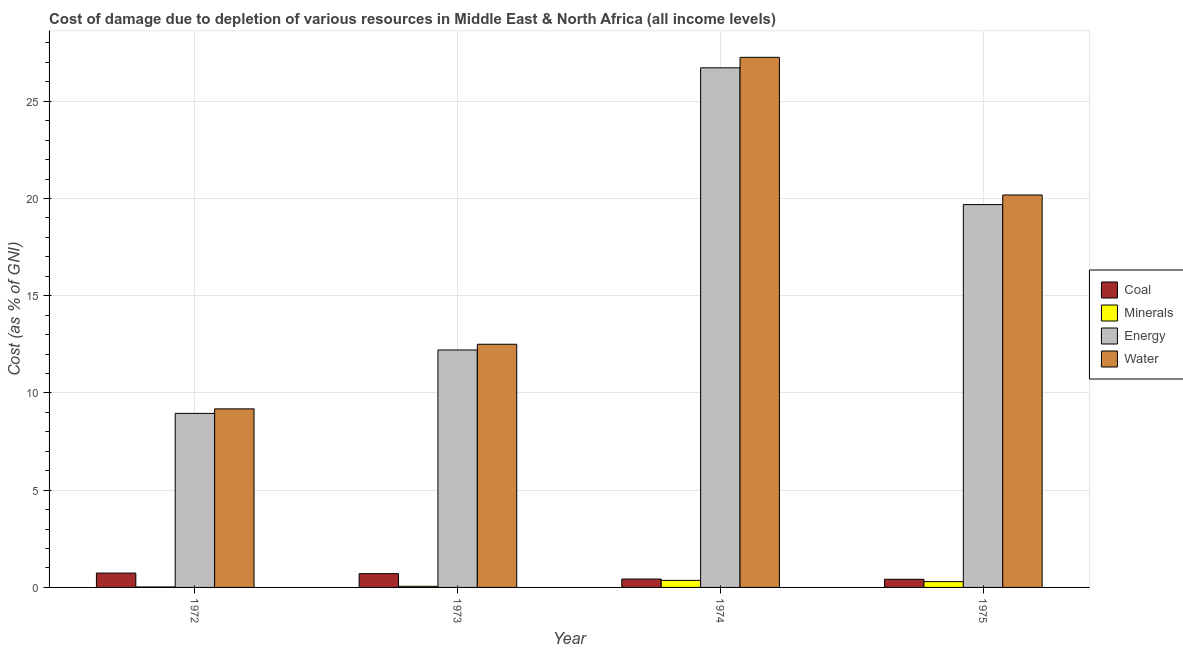How many different coloured bars are there?
Your response must be concise. 4. Are the number of bars on each tick of the X-axis equal?
Offer a very short reply. Yes. How many bars are there on the 3rd tick from the left?
Ensure brevity in your answer.  4. What is the label of the 1st group of bars from the left?
Ensure brevity in your answer.  1972. What is the cost of damage due to depletion of water in 1974?
Offer a terse response. 27.26. Across all years, what is the maximum cost of damage due to depletion of minerals?
Your response must be concise. 0.36. Across all years, what is the minimum cost of damage due to depletion of water?
Your answer should be very brief. 9.18. In which year was the cost of damage due to depletion of energy maximum?
Your answer should be compact. 1974. In which year was the cost of damage due to depletion of coal minimum?
Offer a terse response. 1975. What is the total cost of damage due to depletion of coal in the graph?
Provide a succinct answer. 2.3. What is the difference between the cost of damage due to depletion of water in 1972 and that in 1973?
Keep it short and to the point. -3.32. What is the difference between the cost of damage due to depletion of water in 1974 and the cost of damage due to depletion of minerals in 1972?
Offer a terse response. 18.08. What is the average cost of damage due to depletion of water per year?
Provide a short and direct response. 17.28. In how many years, is the cost of damage due to depletion of coal greater than 11 %?
Provide a succinct answer. 0. What is the ratio of the cost of damage due to depletion of coal in 1973 to that in 1975?
Provide a succinct answer. 1.69. Is the cost of damage due to depletion of coal in 1972 less than that in 1973?
Provide a succinct answer. No. What is the difference between the highest and the second highest cost of damage due to depletion of minerals?
Your answer should be very brief. 0.06. What is the difference between the highest and the lowest cost of damage due to depletion of coal?
Your answer should be compact. 0.32. Is the sum of the cost of damage due to depletion of water in 1972 and 1974 greater than the maximum cost of damage due to depletion of energy across all years?
Give a very brief answer. Yes. What does the 3rd bar from the left in 1975 represents?
Your response must be concise. Energy. What does the 1st bar from the right in 1975 represents?
Provide a short and direct response. Water. Is it the case that in every year, the sum of the cost of damage due to depletion of coal and cost of damage due to depletion of minerals is greater than the cost of damage due to depletion of energy?
Keep it short and to the point. No. How many years are there in the graph?
Give a very brief answer. 4. What is the difference between two consecutive major ticks on the Y-axis?
Provide a short and direct response. 5. Are the values on the major ticks of Y-axis written in scientific E-notation?
Provide a succinct answer. No. Does the graph contain grids?
Give a very brief answer. Yes. How many legend labels are there?
Provide a short and direct response. 4. How are the legend labels stacked?
Ensure brevity in your answer.  Vertical. What is the title of the graph?
Ensure brevity in your answer.  Cost of damage due to depletion of various resources in Middle East & North Africa (all income levels) . Does "Industry" appear as one of the legend labels in the graph?
Keep it short and to the point. No. What is the label or title of the Y-axis?
Offer a terse response. Cost (as % of GNI). What is the Cost (as % of GNI) in Coal in 1972?
Offer a terse response. 0.74. What is the Cost (as % of GNI) in Minerals in 1972?
Make the answer very short. 0.02. What is the Cost (as % of GNI) in Energy in 1972?
Offer a very short reply. 8.95. What is the Cost (as % of GNI) in Water in 1972?
Your answer should be very brief. 9.18. What is the Cost (as % of GNI) of Coal in 1973?
Offer a very short reply. 0.71. What is the Cost (as % of GNI) of Minerals in 1973?
Ensure brevity in your answer.  0.06. What is the Cost (as % of GNI) in Energy in 1973?
Offer a terse response. 12.21. What is the Cost (as % of GNI) of Water in 1973?
Offer a terse response. 12.5. What is the Cost (as % of GNI) in Coal in 1974?
Your answer should be compact. 0.43. What is the Cost (as % of GNI) in Minerals in 1974?
Your response must be concise. 0.36. What is the Cost (as % of GNI) of Energy in 1974?
Provide a succinct answer. 26.72. What is the Cost (as % of GNI) in Water in 1974?
Your answer should be compact. 27.26. What is the Cost (as % of GNI) in Coal in 1975?
Your answer should be very brief. 0.42. What is the Cost (as % of GNI) in Minerals in 1975?
Offer a terse response. 0.3. What is the Cost (as % of GNI) in Energy in 1975?
Your response must be concise. 19.69. What is the Cost (as % of GNI) of Water in 1975?
Make the answer very short. 20.18. Across all years, what is the maximum Cost (as % of GNI) of Coal?
Provide a short and direct response. 0.74. Across all years, what is the maximum Cost (as % of GNI) of Minerals?
Your response must be concise. 0.36. Across all years, what is the maximum Cost (as % of GNI) in Energy?
Provide a short and direct response. 26.72. Across all years, what is the maximum Cost (as % of GNI) of Water?
Provide a succinct answer. 27.26. Across all years, what is the minimum Cost (as % of GNI) of Coal?
Provide a short and direct response. 0.42. Across all years, what is the minimum Cost (as % of GNI) in Minerals?
Provide a succinct answer. 0.02. Across all years, what is the minimum Cost (as % of GNI) in Energy?
Offer a terse response. 8.95. Across all years, what is the minimum Cost (as % of GNI) in Water?
Offer a very short reply. 9.18. What is the total Cost (as % of GNI) in Coal in the graph?
Your answer should be very brief. 2.3. What is the total Cost (as % of GNI) of Minerals in the graph?
Provide a short and direct response. 0.74. What is the total Cost (as % of GNI) in Energy in the graph?
Provide a succinct answer. 67.57. What is the total Cost (as % of GNI) in Water in the graph?
Your response must be concise. 69.13. What is the difference between the Cost (as % of GNI) of Coal in 1972 and that in 1973?
Offer a terse response. 0.03. What is the difference between the Cost (as % of GNI) of Minerals in 1972 and that in 1973?
Ensure brevity in your answer.  -0.03. What is the difference between the Cost (as % of GNI) of Energy in 1972 and that in 1973?
Your answer should be compact. -3.26. What is the difference between the Cost (as % of GNI) in Water in 1972 and that in 1973?
Give a very brief answer. -3.32. What is the difference between the Cost (as % of GNI) of Coal in 1972 and that in 1974?
Provide a short and direct response. 0.31. What is the difference between the Cost (as % of GNI) of Minerals in 1972 and that in 1974?
Make the answer very short. -0.34. What is the difference between the Cost (as % of GNI) in Energy in 1972 and that in 1974?
Keep it short and to the point. -17.77. What is the difference between the Cost (as % of GNI) in Water in 1972 and that in 1974?
Provide a succinct answer. -18.08. What is the difference between the Cost (as % of GNI) of Coal in 1972 and that in 1975?
Ensure brevity in your answer.  0.32. What is the difference between the Cost (as % of GNI) of Minerals in 1972 and that in 1975?
Make the answer very short. -0.27. What is the difference between the Cost (as % of GNI) in Energy in 1972 and that in 1975?
Your answer should be compact. -10.74. What is the difference between the Cost (as % of GNI) in Water in 1972 and that in 1975?
Provide a succinct answer. -11. What is the difference between the Cost (as % of GNI) of Coal in 1973 and that in 1974?
Provide a short and direct response. 0.28. What is the difference between the Cost (as % of GNI) of Minerals in 1973 and that in 1974?
Offer a terse response. -0.3. What is the difference between the Cost (as % of GNI) of Energy in 1973 and that in 1974?
Keep it short and to the point. -14.51. What is the difference between the Cost (as % of GNI) in Water in 1973 and that in 1974?
Your answer should be very brief. -14.76. What is the difference between the Cost (as % of GNI) in Coal in 1973 and that in 1975?
Your response must be concise. 0.29. What is the difference between the Cost (as % of GNI) in Minerals in 1973 and that in 1975?
Give a very brief answer. -0.24. What is the difference between the Cost (as % of GNI) of Energy in 1973 and that in 1975?
Your answer should be very brief. -7.48. What is the difference between the Cost (as % of GNI) in Water in 1973 and that in 1975?
Make the answer very short. -7.68. What is the difference between the Cost (as % of GNI) in Coal in 1974 and that in 1975?
Offer a terse response. 0.01. What is the difference between the Cost (as % of GNI) of Minerals in 1974 and that in 1975?
Your answer should be compact. 0.06. What is the difference between the Cost (as % of GNI) in Energy in 1974 and that in 1975?
Your response must be concise. 7.03. What is the difference between the Cost (as % of GNI) of Water in 1974 and that in 1975?
Offer a very short reply. 7.08. What is the difference between the Cost (as % of GNI) of Coal in 1972 and the Cost (as % of GNI) of Minerals in 1973?
Your response must be concise. 0.68. What is the difference between the Cost (as % of GNI) of Coal in 1972 and the Cost (as % of GNI) of Energy in 1973?
Provide a short and direct response. -11.47. What is the difference between the Cost (as % of GNI) of Coal in 1972 and the Cost (as % of GNI) of Water in 1973?
Your response must be concise. -11.77. What is the difference between the Cost (as % of GNI) of Minerals in 1972 and the Cost (as % of GNI) of Energy in 1973?
Provide a short and direct response. -12.19. What is the difference between the Cost (as % of GNI) in Minerals in 1972 and the Cost (as % of GNI) in Water in 1973?
Keep it short and to the point. -12.48. What is the difference between the Cost (as % of GNI) in Energy in 1972 and the Cost (as % of GNI) in Water in 1973?
Keep it short and to the point. -3.56. What is the difference between the Cost (as % of GNI) in Coal in 1972 and the Cost (as % of GNI) in Minerals in 1974?
Offer a terse response. 0.38. What is the difference between the Cost (as % of GNI) in Coal in 1972 and the Cost (as % of GNI) in Energy in 1974?
Offer a very short reply. -25.98. What is the difference between the Cost (as % of GNI) in Coal in 1972 and the Cost (as % of GNI) in Water in 1974?
Provide a short and direct response. -26.52. What is the difference between the Cost (as % of GNI) of Minerals in 1972 and the Cost (as % of GNI) of Energy in 1974?
Provide a succinct answer. -26.7. What is the difference between the Cost (as % of GNI) in Minerals in 1972 and the Cost (as % of GNI) in Water in 1974?
Your response must be concise. -27.24. What is the difference between the Cost (as % of GNI) in Energy in 1972 and the Cost (as % of GNI) in Water in 1974?
Offer a terse response. -18.31. What is the difference between the Cost (as % of GNI) in Coal in 1972 and the Cost (as % of GNI) in Minerals in 1975?
Offer a terse response. 0.44. What is the difference between the Cost (as % of GNI) of Coal in 1972 and the Cost (as % of GNI) of Energy in 1975?
Keep it short and to the point. -18.95. What is the difference between the Cost (as % of GNI) in Coal in 1972 and the Cost (as % of GNI) in Water in 1975?
Offer a very short reply. -19.44. What is the difference between the Cost (as % of GNI) in Minerals in 1972 and the Cost (as % of GNI) in Energy in 1975?
Give a very brief answer. -19.66. What is the difference between the Cost (as % of GNI) in Minerals in 1972 and the Cost (as % of GNI) in Water in 1975?
Your answer should be compact. -20.16. What is the difference between the Cost (as % of GNI) of Energy in 1972 and the Cost (as % of GNI) of Water in 1975?
Your response must be concise. -11.23. What is the difference between the Cost (as % of GNI) in Coal in 1973 and the Cost (as % of GNI) in Minerals in 1974?
Provide a succinct answer. 0.35. What is the difference between the Cost (as % of GNI) in Coal in 1973 and the Cost (as % of GNI) in Energy in 1974?
Provide a short and direct response. -26.01. What is the difference between the Cost (as % of GNI) of Coal in 1973 and the Cost (as % of GNI) of Water in 1974?
Make the answer very short. -26.55. What is the difference between the Cost (as % of GNI) of Minerals in 1973 and the Cost (as % of GNI) of Energy in 1974?
Your answer should be very brief. -26.66. What is the difference between the Cost (as % of GNI) of Minerals in 1973 and the Cost (as % of GNI) of Water in 1974?
Provide a succinct answer. -27.2. What is the difference between the Cost (as % of GNI) in Energy in 1973 and the Cost (as % of GNI) in Water in 1974?
Give a very brief answer. -15.05. What is the difference between the Cost (as % of GNI) in Coal in 1973 and the Cost (as % of GNI) in Minerals in 1975?
Make the answer very short. 0.41. What is the difference between the Cost (as % of GNI) of Coal in 1973 and the Cost (as % of GNI) of Energy in 1975?
Provide a succinct answer. -18.98. What is the difference between the Cost (as % of GNI) of Coal in 1973 and the Cost (as % of GNI) of Water in 1975?
Offer a terse response. -19.47. What is the difference between the Cost (as % of GNI) in Minerals in 1973 and the Cost (as % of GNI) in Energy in 1975?
Provide a short and direct response. -19.63. What is the difference between the Cost (as % of GNI) in Minerals in 1973 and the Cost (as % of GNI) in Water in 1975?
Give a very brief answer. -20.12. What is the difference between the Cost (as % of GNI) in Energy in 1973 and the Cost (as % of GNI) in Water in 1975?
Keep it short and to the point. -7.97. What is the difference between the Cost (as % of GNI) of Coal in 1974 and the Cost (as % of GNI) of Minerals in 1975?
Make the answer very short. 0.13. What is the difference between the Cost (as % of GNI) of Coal in 1974 and the Cost (as % of GNI) of Energy in 1975?
Ensure brevity in your answer.  -19.26. What is the difference between the Cost (as % of GNI) in Coal in 1974 and the Cost (as % of GNI) in Water in 1975?
Make the answer very short. -19.75. What is the difference between the Cost (as % of GNI) of Minerals in 1974 and the Cost (as % of GNI) of Energy in 1975?
Your answer should be very brief. -19.33. What is the difference between the Cost (as % of GNI) in Minerals in 1974 and the Cost (as % of GNI) in Water in 1975?
Give a very brief answer. -19.82. What is the difference between the Cost (as % of GNI) of Energy in 1974 and the Cost (as % of GNI) of Water in 1975?
Make the answer very short. 6.54. What is the average Cost (as % of GNI) in Coal per year?
Offer a terse response. 0.57. What is the average Cost (as % of GNI) of Minerals per year?
Make the answer very short. 0.19. What is the average Cost (as % of GNI) in Energy per year?
Provide a succinct answer. 16.89. What is the average Cost (as % of GNI) of Water per year?
Keep it short and to the point. 17.28. In the year 1972, what is the difference between the Cost (as % of GNI) of Coal and Cost (as % of GNI) of Minerals?
Keep it short and to the point. 0.71. In the year 1972, what is the difference between the Cost (as % of GNI) in Coal and Cost (as % of GNI) in Energy?
Give a very brief answer. -8.21. In the year 1972, what is the difference between the Cost (as % of GNI) in Coal and Cost (as % of GNI) in Water?
Make the answer very short. -8.44. In the year 1972, what is the difference between the Cost (as % of GNI) of Minerals and Cost (as % of GNI) of Energy?
Offer a very short reply. -8.92. In the year 1972, what is the difference between the Cost (as % of GNI) in Minerals and Cost (as % of GNI) in Water?
Offer a terse response. -9.16. In the year 1972, what is the difference between the Cost (as % of GNI) of Energy and Cost (as % of GNI) of Water?
Give a very brief answer. -0.23. In the year 1973, what is the difference between the Cost (as % of GNI) in Coal and Cost (as % of GNI) in Minerals?
Give a very brief answer. 0.65. In the year 1973, what is the difference between the Cost (as % of GNI) of Coal and Cost (as % of GNI) of Energy?
Offer a very short reply. -11.5. In the year 1973, what is the difference between the Cost (as % of GNI) in Coal and Cost (as % of GNI) in Water?
Offer a terse response. -11.8. In the year 1973, what is the difference between the Cost (as % of GNI) of Minerals and Cost (as % of GNI) of Energy?
Your response must be concise. -12.15. In the year 1973, what is the difference between the Cost (as % of GNI) in Minerals and Cost (as % of GNI) in Water?
Offer a terse response. -12.45. In the year 1973, what is the difference between the Cost (as % of GNI) in Energy and Cost (as % of GNI) in Water?
Keep it short and to the point. -0.29. In the year 1974, what is the difference between the Cost (as % of GNI) of Coal and Cost (as % of GNI) of Minerals?
Provide a short and direct response. 0.07. In the year 1974, what is the difference between the Cost (as % of GNI) in Coal and Cost (as % of GNI) in Energy?
Keep it short and to the point. -26.29. In the year 1974, what is the difference between the Cost (as % of GNI) in Coal and Cost (as % of GNI) in Water?
Your answer should be very brief. -26.83. In the year 1974, what is the difference between the Cost (as % of GNI) in Minerals and Cost (as % of GNI) in Energy?
Give a very brief answer. -26.36. In the year 1974, what is the difference between the Cost (as % of GNI) in Minerals and Cost (as % of GNI) in Water?
Ensure brevity in your answer.  -26.9. In the year 1974, what is the difference between the Cost (as % of GNI) of Energy and Cost (as % of GNI) of Water?
Provide a short and direct response. -0.54. In the year 1975, what is the difference between the Cost (as % of GNI) of Coal and Cost (as % of GNI) of Minerals?
Provide a short and direct response. 0.12. In the year 1975, what is the difference between the Cost (as % of GNI) in Coal and Cost (as % of GNI) in Energy?
Your response must be concise. -19.27. In the year 1975, what is the difference between the Cost (as % of GNI) of Coal and Cost (as % of GNI) of Water?
Your response must be concise. -19.76. In the year 1975, what is the difference between the Cost (as % of GNI) in Minerals and Cost (as % of GNI) in Energy?
Give a very brief answer. -19.39. In the year 1975, what is the difference between the Cost (as % of GNI) of Minerals and Cost (as % of GNI) of Water?
Your response must be concise. -19.88. In the year 1975, what is the difference between the Cost (as % of GNI) in Energy and Cost (as % of GNI) in Water?
Offer a very short reply. -0.49. What is the ratio of the Cost (as % of GNI) of Coal in 1972 to that in 1973?
Keep it short and to the point. 1.04. What is the ratio of the Cost (as % of GNI) of Minerals in 1972 to that in 1973?
Make the answer very short. 0.42. What is the ratio of the Cost (as % of GNI) in Energy in 1972 to that in 1973?
Offer a terse response. 0.73. What is the ratio of the Cost (as % of GNI) in Water in 1972 to that in 1973?
Your answer should be compact. 0.73. What is the ratio of the Cost (as % of GNI) of Coal in 1972 to that in 1974?
Offer a terse response. 1.71. What is the ratio of the Cost (as % of GNI) in Minerals in 1972 to that in 1974?
Your answer should be very brief. 0.07. What is the ratio of the Cost (as % of GNI) in Energy in 1972 to that in 1974?
Keep it short and to the point. 0.33. What is the ratio of the Cost (as % of GNI) of Water in 1972 to that in 1974?
Your answer should be very brief. 0.34. What is the ratio of the Cost (as % of GNI) of Coal in 1972 to that in 1975?
Your answer should be compact. 1.76. What is the ratio of the Cost (as % of GNI) in Minerals in 1972 to that in 1975?
Your answer should be very brief. 0.08. What is the ratio of the Cost (as % of GNI) of Energy in 1972 to that in 1975?
Your answer should be very brief. 0.45. What is the ratio of the Cost (as % of GNI) in Water in 1972 to that in 1975?
Provide a succinct answer. 0.46. What is the ratio of the Cost (as % of GNI) in Coal in 1973 to that in 1974?
Offer a terse response. 1.64. What is the ratio of the Cost (as % of GNI) in Minerals in 1973 to that in 1974?
Your answer should be very brief. 0.16. What is the ratio of the Cost (as % of GNI) of Energy in 1973 to that in 1974?
Offer a terse response. 0.46. What is the ratio of the Cost (as % of GNI) of Water in 1973 to that in 1974?
Your response must be concise. 0.46. What is the ratio of the Cost (as % of GNI) in Coal in 1973 to that in 1975?
Provide a succinct answer. 1.69. What is the ratio of the Cost (as % of GNI) of Minerals in 1973 to that in 1975?
Your answer should be compact. 0.19. What is the ratio of the Cost (as % of GNI) in Energy in 1973 to that in 1975?
Offer a terse response. 0.62. What is the ratio of the Cost (as % of GNI) of Water in 1973 to that in 1975?
Provide a succinct answer. 0.62. What is the ratio of the Cost (as % of GNI) in Coal in 1974 to that in 1975?
Offer a terse response. 1.03. What is the ratio of the Cost (as % of GNI) of Minerals in 1974 to that in 1975?
Your answer should be very brief. 1.21. What is the ratio of the Cost (as % of GNI) in Energy in 1974 to that in 1975?
Make the answer very short. 1.36. What is the ratio of the Cost (as % of GNI) of Water in 1974 to that in 1975?
Your response must be concise. 1.35. What is the difference between the highest and the second highest Cost (as % of GNI) of Coal?
Keep it short and to the point. 0.03. What is the difference between the highest and the second highest Cost (as % of GNI) in Minerals?
Provide a short and direct response. 0.06. What is the difference between the highest and the second highest Cost (as % of GNI) of Energy?
Your answer should be very brief. 7.03. What is the difference between the highest and the second highest Cost (as % of GNI) in Water?
Give a very brief answer. 7.08. What is the difference between the highest and the lowest Cost (as % of GNI) in Coal?
Your response must be concise. 0.32. What is the difference between the highest and the lowest Cost (as % of GNI) in Minerals?
Give a very brief answer. 0.34. What is the difference between the highest and the lowest Cost (as % of GNI) of Energy?
Provide a succinct answer. 17.77. What is the difference between the highest and the lowest Cost (as % of GNI) of Water?
Provide a succinct answer. 18.08. 